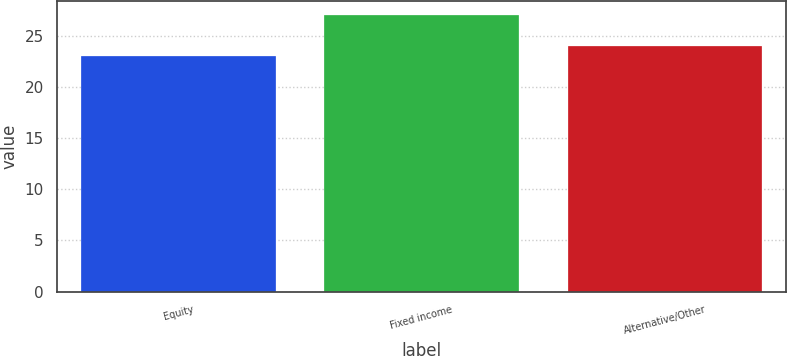Convert chart. <chart><loc_0><loc_0><loc_500><loc_500><bar_chart><fcel>Equity<fcel>Fixed income<fcel>Alternative/Other<nl><fcel>23<fcel>27<fcel>24<nl></chart> 